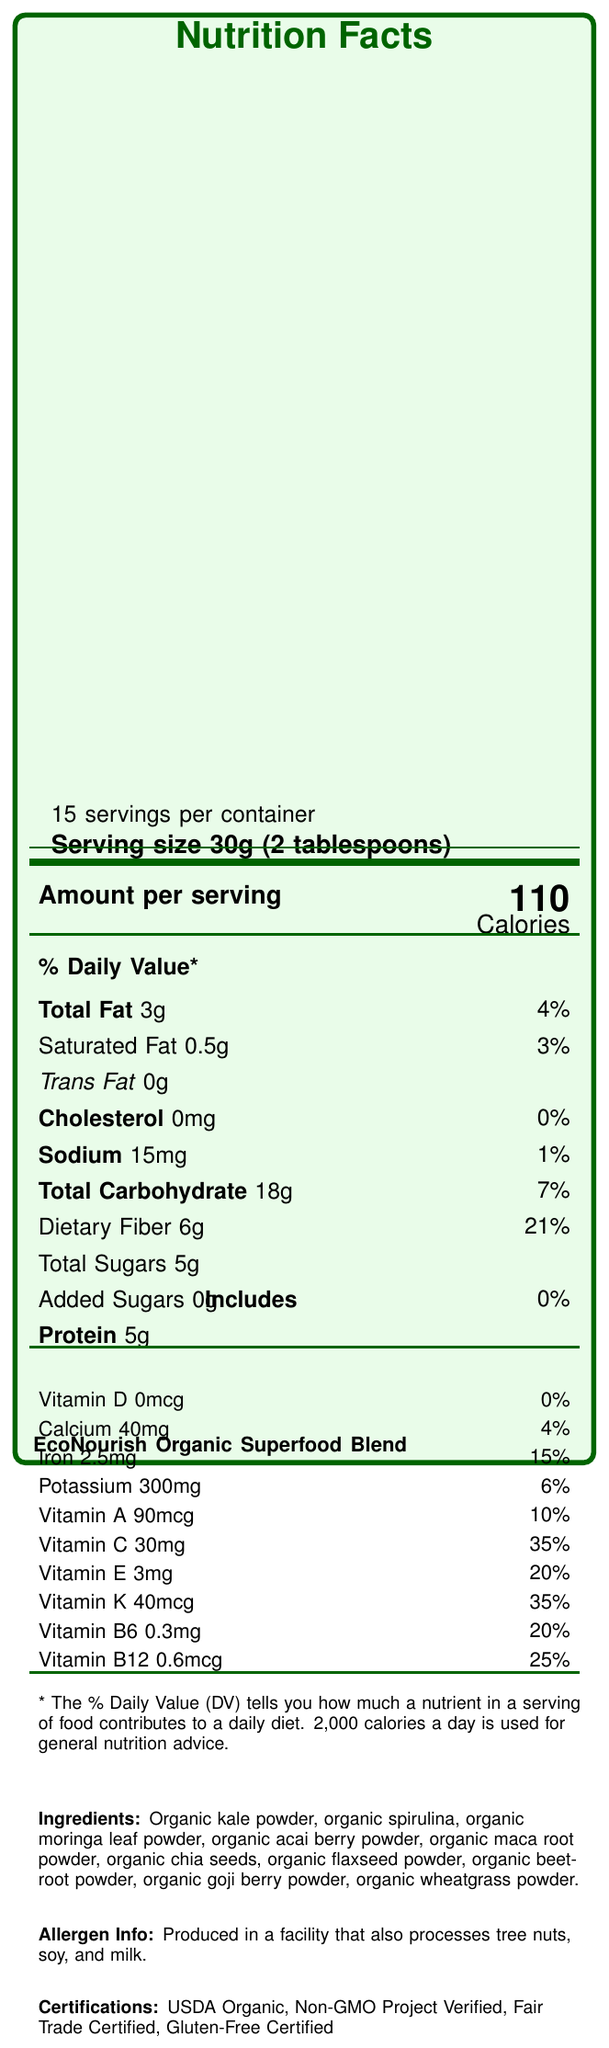What is the product name? The product name is clearly stated at the top and bottom parts of the document.
Answer: EcoNourish Organic Superfood Blend What is the serving size? The serving size is indicated in the first few lines of the document.
Answer: 30g (2 tablespoons) How many servings are in one container? The number of servings per container is listed at the beginning of the document, right below the title "Nutrition Facts".
Answer: 15 How many calories are in one serving? The amount of calories per serving is clearly mentioned next to the term "Calories".
Answer: 110 Which vitamin has the highest % Daily Value? Vitamin C has a daily value of 35%, which is the highest among the listed vitamins.
Answer: Vitamin C Does this product contain trans fat? The document states that the amount of trans fat is 0g.
Answer: No What is the % Daily Value of dietary fiber per serving? The % Daily Value of dietary fiber is given as 21% in the section related to dietary values.
Answer: 21% Are there added sugars in this product? The product contains 0g of added sugars, which is listed along with the notation "0%".
Answer: No Which of the following certifications does the product have? A. USDA Organic B. Gluten-Free Certified C. Non-GMO Project Verified D. All of the above The document lists USDA Organic, Gluten-Free Certified, and Non-GMO Project Verified as certifications, hence the answer is all of the above.
Answer: D. All of the above What is the sodium content per serving? A. 50mg B. 30mg C. 15mg D. 5mg The document states that the sodium content per serving is 15mg.
Answer: C Is this product free from cholesterol? The document clearly states that cholesterol is 0mg.
Answer: Yes Summarize the main features and benefits mentioned in the document. The document provides nutritional details, ingredients, certifications, allergen information, sustainability features, and social impact contributions of the product EcoNourish Organic Superfood Blend. It highlights its purpose and values in targeting food security in underserved communities.
Answer: The EcoNourish Organic Superfood Blend is an organic, nutrient-rich product with various vitamins and minerals. It has a serving size of 30g (2 tablespoons) with 15 servings per container. The product is tailored for dietary needs, containing 110 calories per serving, high fiber, and no added sugars or trans fats. It includes numerous certifications like USDA Organic and fair trade certifications, and contributes to community welfare through donations and partnerships with local food banks. Its sustainability features include compostable packaging and carbon-neutral shipping. What are some of the key ingredients in the product? The document provides a detailed list of key ingredients in the ingredients section.
Answer: Organic kale powder, organic spirulina, organic moringa leaf powder, organic acai berry powder, organic maca root powder, organic chia seeds, organic flaxseed powder, organic beetroot powder, organic goji berry powder, organic wheatgrass powder Can the storage instructions for this product be found on the label? The document provided does not include the storage instructions directly.
Answer: Not enough information What percentage of profits is donated to food security initiatives? The document states that 5% of profits are donated to food security initiatives in underserved communities.
Answer: 5% List one sustainability feature of the product. One of the sustainability features mentioned in the document is compostable packaging.
Answer: Compostable packaging 